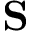<formula> <loc_0><loc_0><loc_500><loc_500>S</formula> 